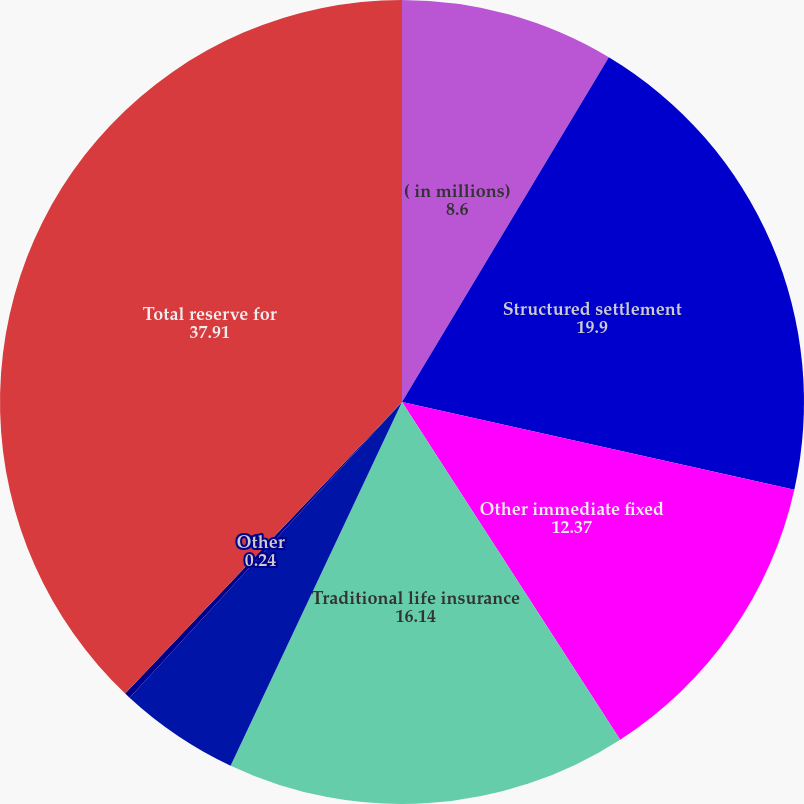<chart> <loc_0><loc_0><loc_500><loc_500><pie_chart><fcel>( in millions)<fcel>Structured settlement<fcel>Other immediate fixed<fcel>Traditional life insurance<fcel>Accident and health insurance<fcel>Other<fcel>Total reserve for<nl><fcel>8.6%<fcel>19.9%<fcel>12.37%<fcel>16.14%<fcel>4.84%<fcel>0.24%<fcel>37.91%<nl></chart> 